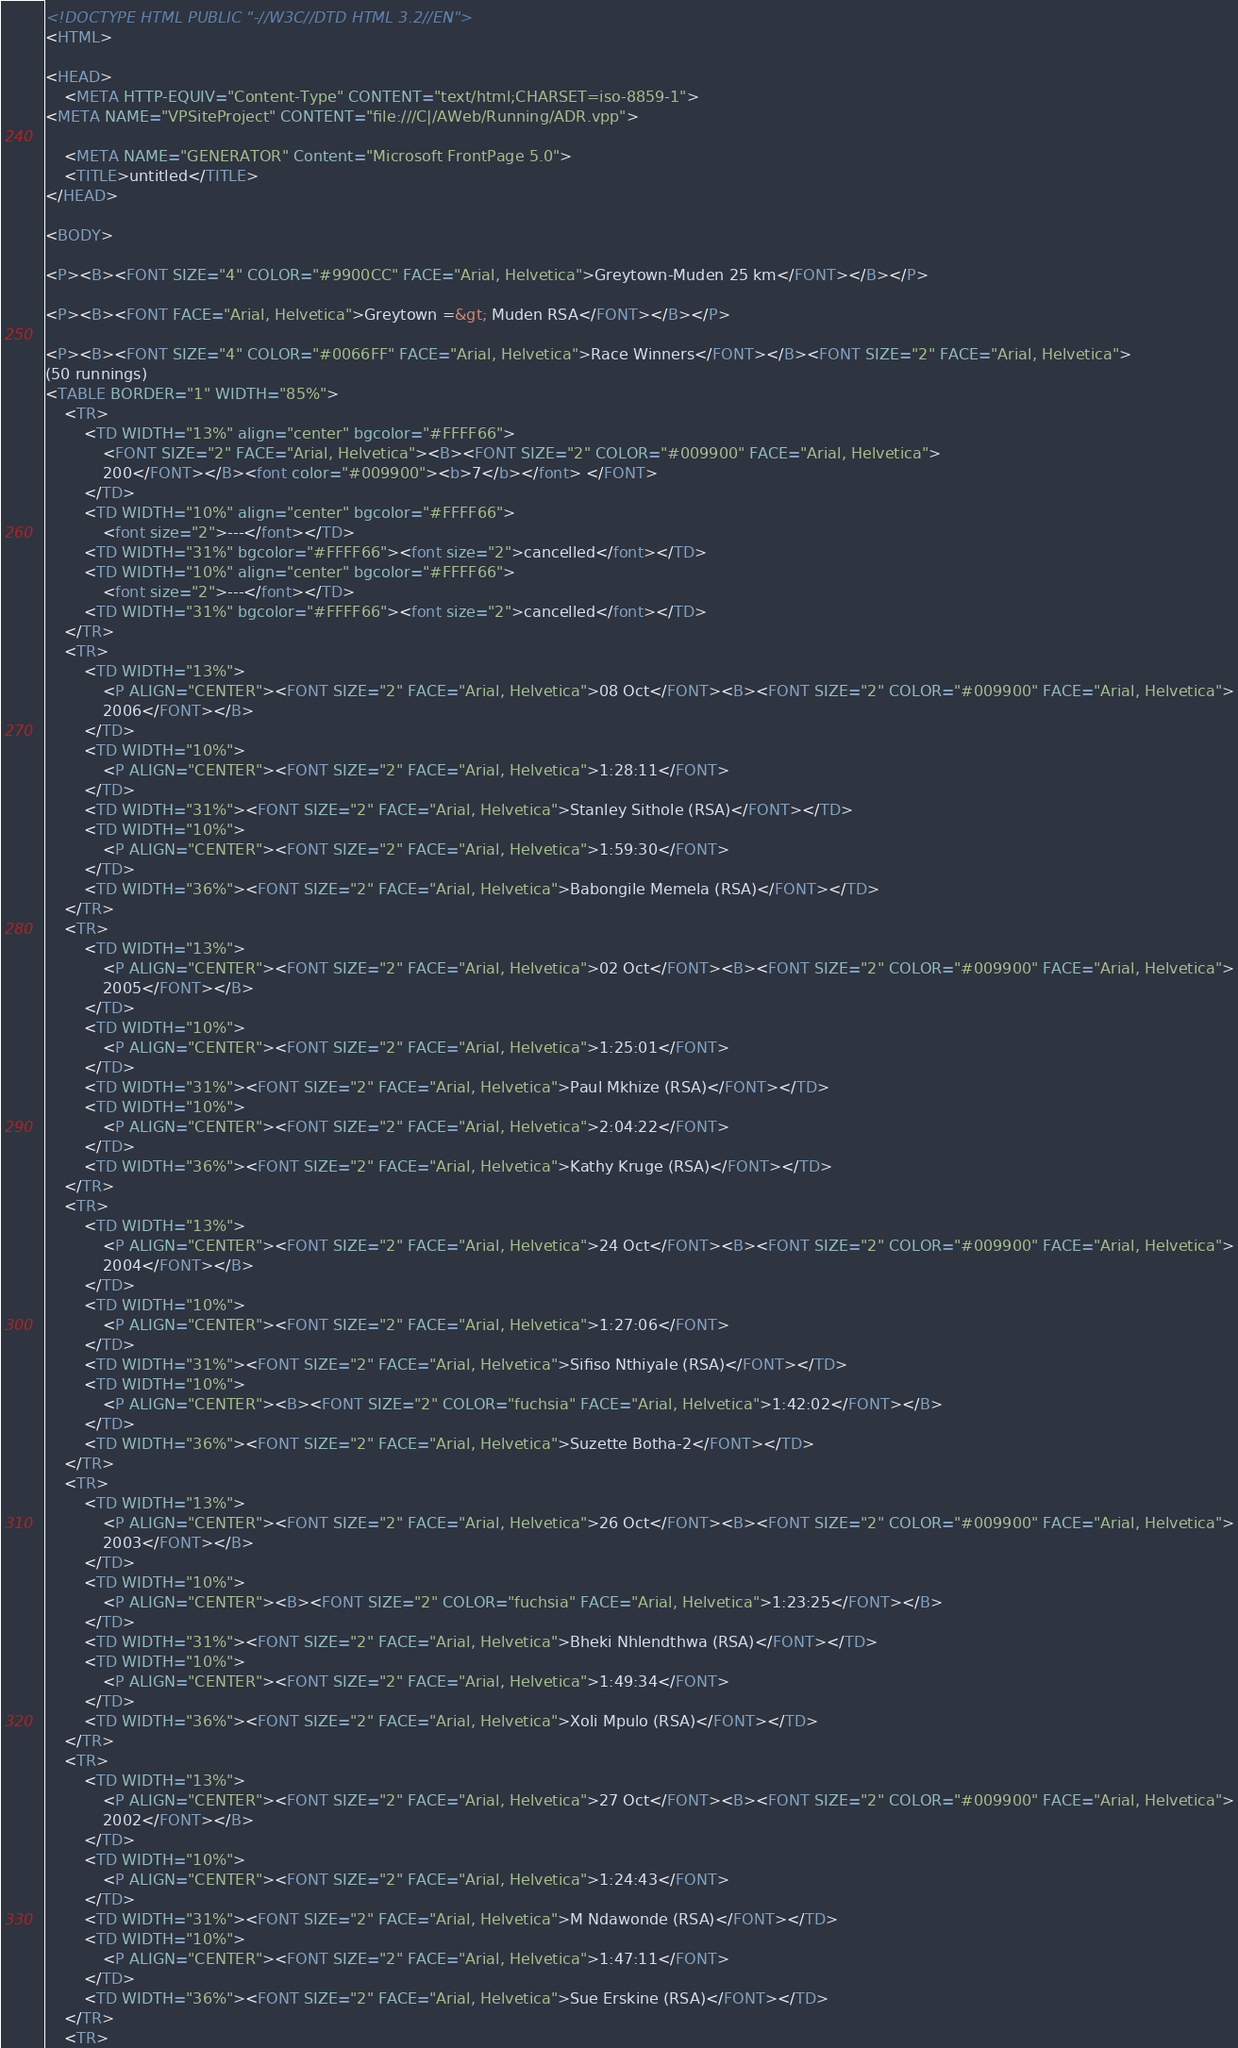Convert code to text. <code><loc_0><loc_0><loc_500><loc_500><_HTML_><!DOCTYPE HTML PUBLIC "-//W3C//DTD HTML 3.2//EN">
<HTML>

<HEAD>
	<META HTTP-EQUIV="Content-Type" CONTENT="text/html;CHARSET=iso-8859-1">
<META NAME="VPSiteProject" CONTENT="file:///C|/AWeb/Running/ADR.vpp">

	<META NAME="GENERATOR" Content="Microsoft FrontPage 5.0">
	<TITLE>untitled</TITLE>
</HEAD>

<BODY>

<P><B><FONT SIZE="4" COLOR="#9900CC" FACE="Arial, Helvetica">Greytown-Muden 25 km</FONT></B></P>

<P><B><FONT FACE="Arial, Helvetica">Greytown =&gt; Muden RSA</FONT></B></P>

<P><B><FONT SIZE="4" COLOR="#0066FF" FACE="Arial, Helvetica">Race Winners</FONT></B><FONT SIZE="2" FACE="Arial, Helvetica">
(50 runnings) 
<TABLE BORDER="1" WIDTH="85%">
	<TR>
		<TD WIDTH="13%" align="center" bgcolor="#FFFF66">
			<FONT SIZE="2" FACE="Arial, Helvetica"><B><FONT SIZE="2" COLOR="#009900" FACE="Arial, Helvetica">
            200</FONT></B><font color="#009900"><b>7</b></font> </FONT>
		</TD>
		<TD WIDTH="10%" align="center" bgcolor="#FFFF66">
			<font size="2">---</font></TD>
		<TD WIDTH="31%" bgcolor="#FFFF66"><font size="2">cancelled</font></TD>
		<TD WIDTH="10%" align="center" bgcolor="#FFFF66">
			<font size="2">---</font></TD>
		<TD WIDTH="31%" bgcolor="#FFFF66"><font size="2">cancelled</font></TD>
	</TR>
	<TR>
		<TD WIDTH="13%">
			<P ALIGN="CENTER"><FONT SIZE="2" FACE="Arial, Helvetica">08 Oct</FONT><B><FONT SIZE="2" COLOR="#009900" FACE="Arial, Helvetica">
			2006</FONT></B>
		</TD>
		<TD WIDTH="10%">
			<P ALIGN="CENTER"><FONT SIZE="2" FACE="Arial, Helvetica">1:28:11</FONT>
		</TD>
		<TD WIDTH="31%"><FONT SIZE="2" FACE="Arial, Helvetica">Stanley Sithole (RSA)</FONT></TD>
		<TD WIDTH="10%">
			<P ALIGN="CENTER"><FONT SIZE="2" FACE="Arial, Helvetica">1:59:30</FONT>
		</TD>
		<TD WIDTH="36%"><FONT SIZE="2" FACE="Arial, Helvetica">Babongile Memela (RSA)</FONT></TD>
	</TR>
	<TR>
		<TD WIDTH="13%">
			<P ALIGN="CENTER"><FONT SIZE="2" FACE="Arial, Helvetica">02 Oct</FONT><B><FONT SIZE="2" COLOR="#009900" FACE="Arial, Helvetica">
			2005</FONT></B>
		</TD>
		<TD WIDTH="10%">
			<P ALIGN="CENTER"><FONT SIZE="2" FACE="Arial, Helvetica">1:25:01</FONT>
		</TD>
		<TD WIDTH="31%"><FONT SIZE="2" FACE="Arial, Helvetica">Paul Mkhize (RSA)</FONT></TD>
		<TD WIDTH="10%">
			<P ALIGN="CENTER"><FONT SIZE="2" FACE="Arial, Helvetica">2:04:22</FONT>
		</TD>
		<TD WIDTH="36%"><FONT SIZE="2" FACE="Arial, Helvetica">Kathy Kruge (RSA)</FONT></TD>
	</TR>
	<TR>
		<TD WIDTH="13%">
			<P ALIGN="CENTER"><FONT SIZE="2" FACE="Arial, Helvetica">24 Oct</FONT><B><FONT SIZE="2" COLOR="#009900" FACE="Arial, Helvetica">
			2004</FONT></B>
		</TD>
		<TD WIDTH="10%">
			<P ALIGN="CENTER"><FONT SIZE="2" FACE="Arial, Helvetica">1:27:06</FONT>
		</TD>
		<TD WIDTH="31%"><FONT SIZE="2" FACE="Arial, Helvetica">Sifiso Nthiyale (RSA)</FONT></TD>
		<TD WIDTH="10%">
			<P ALIGN="CENTER"><B><FONT SIZE="2" COLOR="fuchsia" FACE="Arial, Helvetica">1:42:02</FONT></B>
		</TD>
		<TD WIDTH="36%"><FONT SIZE="2" FACE="Arial, Helvetica">Suzette Botha-2</FONT></TD>
	</TR>
	<TR>
		<TD WIDTH="13%">
			<P ALIGN="CENTER"><FONT SIZE="2" FACE="Arial, Helvetica">26 Oct</FONT><B><FONT SIZE="2" COLOR="#009900" FACE="Arial, Helvetica">
			2003</FONT></B>
		</TD>
		<TD WIDTH="10%">
			<P ALIGN="CENTER"><B><FONT SIZE="2" COLOR="fuchsia" FACE="Arial, Helvetica">1:23:25</FONT></B>
		</TD>
		<TD WIDTH="31%"><FONT SIZE="2" FACE="Arial, Helvetica">Bheki Nhlendthwa (RSA)</FONT></TD>
		<TD WIDTH="10%">
			<P ALIGN="CENTER"><FONT SIZE="2" FACE="Arial, Helvetica">1:49:34</FONT>
		</TD>
		<TD WIDTH="36%"><FONT SIZE="2" FACE="Arial, Helvetica">Xoli Mpulo (RSA)</FONT></TD>
	</TR>
	<TR>
		<TD WIDTH="13%">
			<P ALIGN="CENTER"><FONT SIZE="2" FACE="Arial, Helvetica">27 Oct</FONT><B><FONT SIZE="2" COLOR="#009900" FACE="Arial, Helvetica">
			2002</FONT></B>
		</TD>
		<TD WIDTH="10%">
			<P ALIGN="CENTER"><FONT SIZE="2" FACE="Arial, Helvetica">1:24:43</FONT>
		</TD>
		<TD WIDTH="31%"><FONT SIZE="2" FACE="Arial, Helvetica">M Ndawonde (RSA)</FONT></TD>
		<TD WIDTH="10%">
			<P ALIGN="CENTER"><FONT SIZE="2" FACE="Arial, Helvetica">1:47:11</FONT>
		</TD>
		<TD WIDTH="36%"><FONT SIZE="2" FACE="Arial, Helvetica">Sue Erskine (RSA)</FONT></TD>
	</TR>
	<TR></code> 